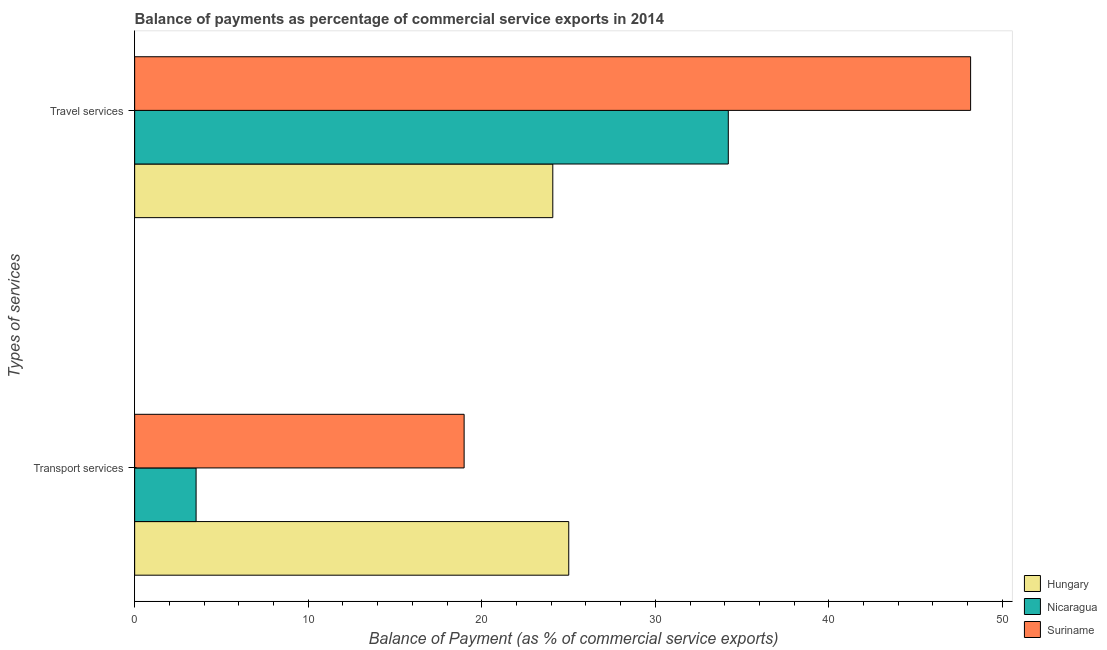How many groups of bars are there?
Give a very brief answer. 2. Are the number of bars per tick equal to the number of legend labels?
Your answer should be compact. Yes. Are the number of bars on each tick of the Y-axis equal?
Keep it short and to the point. Yes. How many bars are there on the 1st tick from the top?
Your answer should be very brief. 3. What is the label of the 2nd group of bars from the top?
Your response must be concise. Transport services. What is the balance of payments of transport services in Hungary?
Ensure brevity in your answer.  25.01. Across all countries, what is the maximum balance of payments of travel services?
Your answer should be very brief. 48.17. Across all countries, what is the minimum balance of payments of transport services?
Offer a very short reply. 3.54. In which country was the balance of payments of travel services maximum?
Provide a short and direct response. Suriname. In which country was the balance of payments of transport services minimum?
Ensure brevity in your answer.  Nicaragua. What is the total balance of payments of travel services in the graph?
Provide a succinct answer. 106.47. What is the difference between the balance of payments of transport services in Hungary and that in Suriname?
Your response must be concise. 6.03. What is the difference between the balance of payments of travel services in Suriname and the balance of payments of transport services in Hungary?
Make the answer very short. 23.16. What is the average balance of payments of transport services per country?
Offer a very short reply. 15.85. What is the difference between the balance of payments of transport services and balance of payments of travel services in Hungary?
Ensure brevity in your answer.  0.92. What is the ratio of the balance of payments of travel services in Suriname to that in Hungary?
Provide a short and direct response. 2. What does the 1st bar from the top in Transport services represents?
Ensure brevity in your answer.  Suriname. What does the 1st bar from the bottom in Transport services represents?
Provide a short and direct response. Hungary. How many bars are there?
Your answer should be compact. 6. Are all the bars in the graph horizontal?
Keep it short and to the point. Yes. Are the values on the major ticks of X-axis written in scientific E-notation?
Offer a terse response. No. Does the graph contain any zero values?
Your answer should be very brief. No. Does the graph contain grids?
Give a very brief answer. No. Where does the legend appear in the graph?
Provide a short and direct response. Bottom right. How many legend labels are there?
Offer a very short reply. 3. How are the legend labels stacked?
Ensure brevity in your answer.  Vertical. What is the title of the graph?
Make the answer very short. Balance of payments as percentage of commercial service exports in 2014. Does "Turkmenistan" appear as one of the legend labels in the graph?
Provide a succinct answer. No. What is the label or title of the X-axis?
Give a very brief answer. Balance of Payment (as % of commercial service exports). What is the label or title of the Y-axis?
Your answer should be compact. Types of services. What is the Balance of Payment (as % of commercial service exports) of Hungary in Transport services?
Offer a terse response. 25.01. What is the Balance of Payment (as % of commercial service exports) of Nicaragua in Transport services?
Provide a succinct answer. 3.54. What is the Balance of Payment (as % of commercial service exports) in Suriname in Transport services?
Keep it short and to the point. 18.99. What is the Balance of Payment (as % of commercial service exports) in Hungary in Travel services?
Make the answer very short. 24.09. What is the Balance of Payment (as % of commercial service exports) in Nicaragua in Travel services?
Ensure brevity in your answer.  34.21. What is the Balance of Payment (as % of commercial service exports) in Suriname in Travel services?
Give a very brief answer. 48.17. Across all Types of services, what is the maximum Balance of Payment (as % of commercial service exports) of Hungary?
Offer a terse response. 25.01. Across all Types of services, what is the maximum Balance of Payment (as % of commercial service exports) in Nicaragua?
Offer a very short reply. 34.21. Across all Types of services, what is the maximum Balance of Payment (as % of commercial service exports) in Suriname?
Ensure brevity in your answer.  48.17. Across all Types of services, what is the minimum Balance of Payment (as % of commercial service exports) in Hungary?
Provide a short and direct response. 24.09. Across all Types of services, what is the minimum Balance of Payment (as % of commercial service exports) in Nicaragua?
Your answer should be very brief. 3.54. Across all Types of services, what is the minimum Balance of Payment (as % of commercial service exports) of Suriname?
Keep it short and to the point. 18.99. What is the total Balance of Payment (as % of commercial service exports) of Hungary in the graph?
Ensure brevity in your answer.  49.11. What is the total Balance of Payment (as % of commercial service exports) of Nicaragua in the graph?
Ensure brevity in your answer.  37.75. What is the total Balance of Payment (as % of commercial service exports) in Suriname in the graph?
Give a very brief answer. 67.15. What is the difference between the Balance of Payment (as % of commercial service exports) in Hungary in Transport services and that in Travel services?
Offer a terse response. 0.92. What is the difference between the Balance of Payment (as % of commercial service exports) in Nicaragua in Transport services and that in Travel services?
Your answer should be compact. -30.67. What is the difference between the Balance of Payment (as % of commercial service exports) in Suriname in Transport services and that in Travel services?
Your answer should be very brief. -29.18. What is the difference between the Balance of Payment (as % of commercial service exports) of Hungary in Transport services and the Balance of Payment (as % of commercial service exports) of Nicaragua in Travel services?
Give a very brief answer. -9.19. What is the difference between the Balance of Payment (as % of commercial service exports) in Hungary in Transport services and the Balance of Payment (as % of commercial service exports) in Suriname in Travel services?
Give a very brief answer. -23.16. What is the difference between the Balance of Payment (as % of commercial service exports) in Nicaragua in Transport services and the Balance of Payment (as % of commercial service exports) in Suriname in Travel services?
Your answer should be compact. -44.63. What is the average Balance of Payment (as % of commercial service exports) of Hungary per Types of services?
Offer a very short reply. 24.55. What is the average Balance of Payment (as % of commercial service exports) of Nicaragua per Types of services?
Make the answer very short. 18.87. What is the average Balance of Payment (as % of commercial service exports) of Suriname per Types of services?
Your response must be concise. 33.58. What is the difference between the Balance of Payment (as % of commercial service exports) of Hungary and Balance of Payment (as % of commercial service exports) of Nicaragua in Transport services?
Your response must be concise. 21.47. What is the difference between the Balance of Payment (as % of commercial service exports) in Hungary and Balance of Payment (as % of commercial service exports) in Suriname in Transport services?
Ensure brevity in your answer.  6.03. What is the difference between the Balance of Payment (as % of commercial service exports) of Nicaragua and Balance of Payment (as % of commercial service exports) of Suriname in Transport services?
Provide a succinct answer. -15.44. What is the difference between the Balance of Payment (as % of commercial service exports) of Hungary and Balance of Payment (as % of commercial service exports) of Nicaragua in Travel services?
Make the answer very short. -10.11. What is the difference between the Balance of Payment (as % of commercial service exports) of Hungary and Balance of Payment (as % of commercial service exports) of Suriname in Travel services?
Keep it short and to the point. -24.08. What is the difference between the Balance of Payment (as % of commercial service exports) of Nicaragua and Balance of Payment (as % of commercial service exports) of Suriname in Travel services?
Your response must be concise. -13.96. What is the ratio of the Balance of Payment (as % of commercial service exports) in Hungary in Transport services to that in Travel services?
Ensure brevity in your answer.  1.04. What is the ratio of the Balance of Payment (as % of commercial service exports) of Nicaragua in Transport services to that in Travel services?
Keep it short and to the point. 0.1. What is the ratio of the Balance of Payment (as % of commercial service exports) of Suriname in Transport services to that in Travel services?
Make the answer very short. 0.39. What is the difference between the highest and the second highest Balance of Payment (as % of commercial service exports) of Hungary?
Offer a very short reply. 0.92. What is the difference between the highest and the second highest Balance of Payment (as % of commercial service exports) in Nicaragua?
Keep it short and to the point. 30.67. What is the difference between the highest and the second highest Balance of Payment (as % of commercial service exports) of Suriname?
Provide a succinct answer. 29.18. What is the difference between the highest and the lowest Balance of Payment (as % of commercial service exports) of Hungary?
Make the answer very short. 0.92. What is the difference between the highest and the lowest Balance of Payment (as % of commercial service exports) of Nicaragua?
Give a very brief answer. 30.67. What is the difference between the highest and the lowest Balance of Payment (as % of commercial service exports) in Suriname?
Provide a short and direct response. 29.18. 